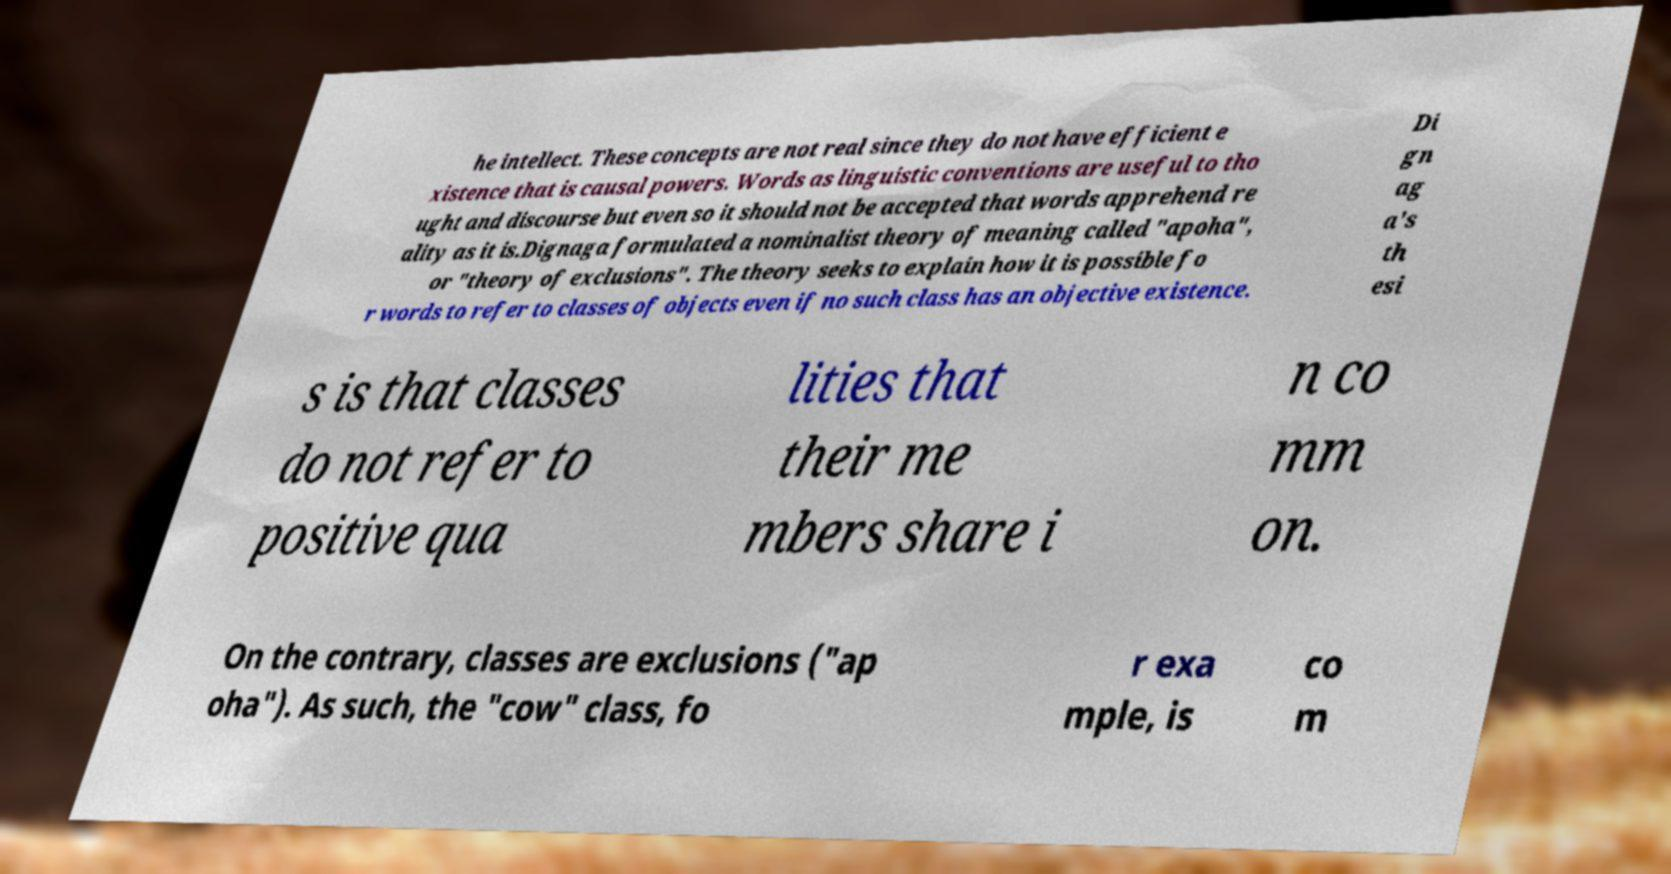Could you assist in decoding the text presented in this image and type it out clearly? he intellect. These concepts are not real since they do not have efficient e xistence that is causal powers. Words as linguistic conventions are useful to tho ught and discourse but even so it should not be accepted that words apprehend re ality as it is.Dignaga formulated a nominalist theory of meaning called "apoha", or "theory of exclusions". The theory seeks to explain how it is possible fo r words to refer to classes of objects even if no such class has an objective existence. Di gn ag a's th esi s is that classes do not refer to positive qua lities that their me mbers share i n co mm on. On the contrary, classes are exclusions ("ap oha"). As such, the "cow" class, fo r exa mple, is co m 